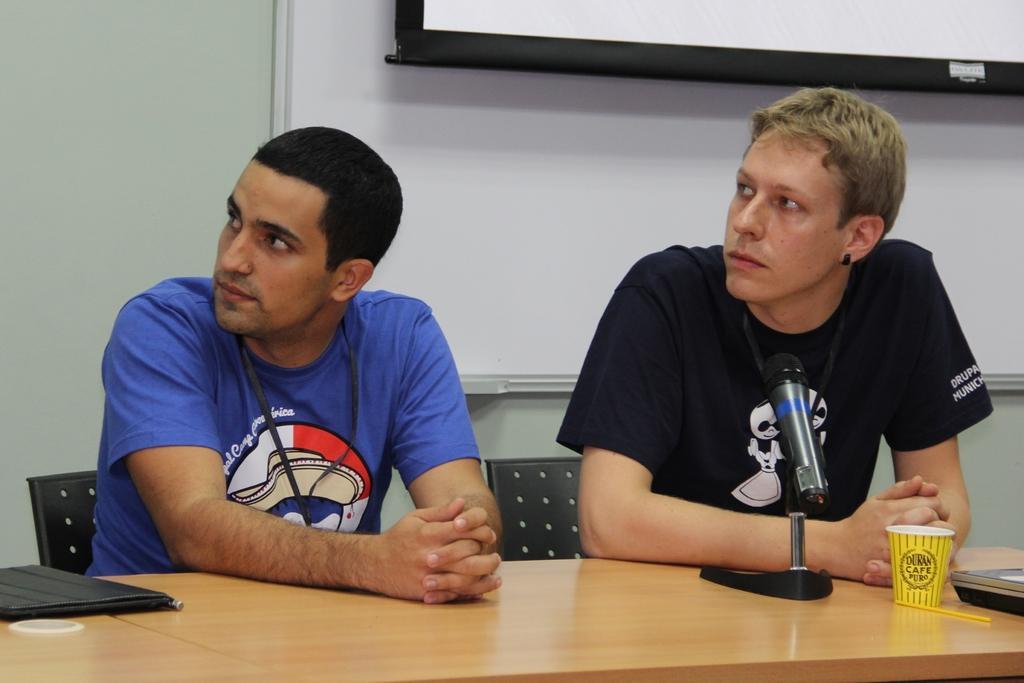Describe this image in one or two sentences. Here we can see a two man who are sitting on a chair and they are looking at someone. This is a wooden table where a file, a microphone and a glass are kept on it. In the background we can see a screen. 